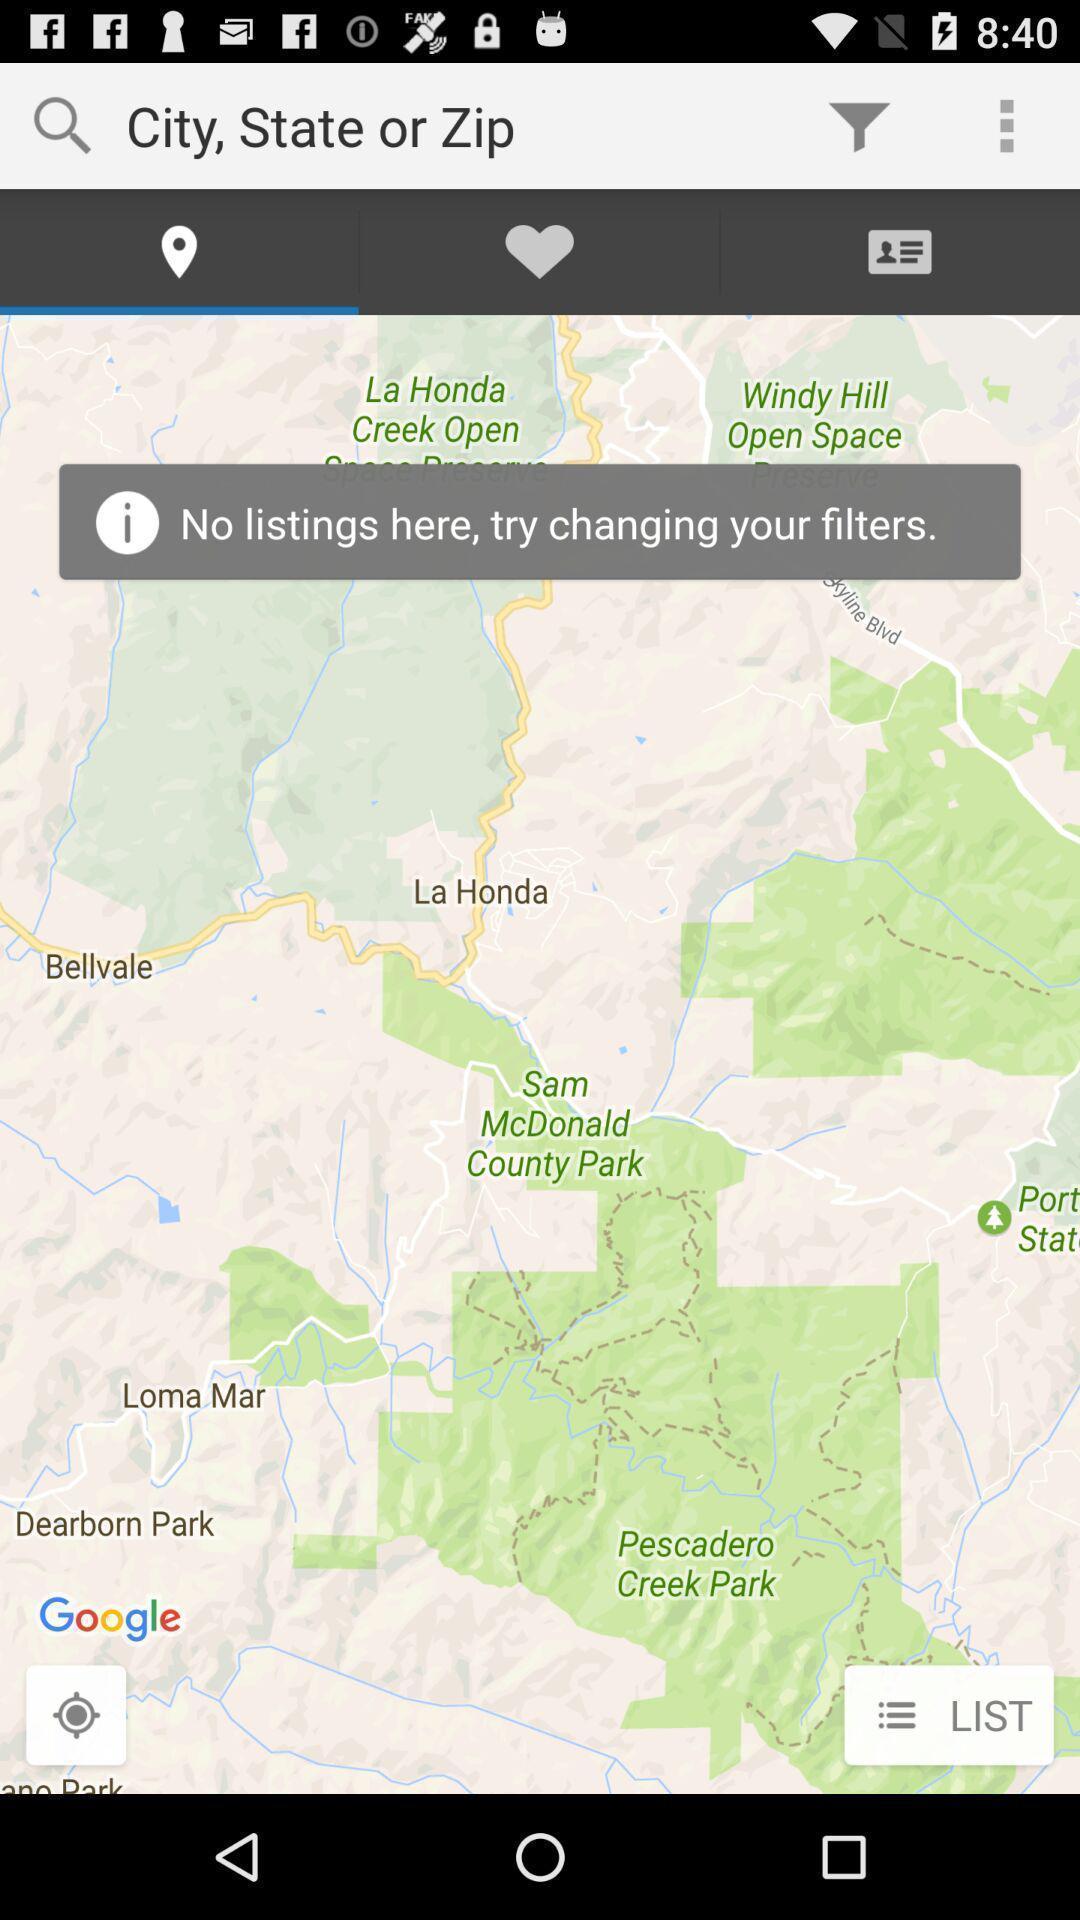Explain what's happening in this screen capture. Page displays different locations in app. 